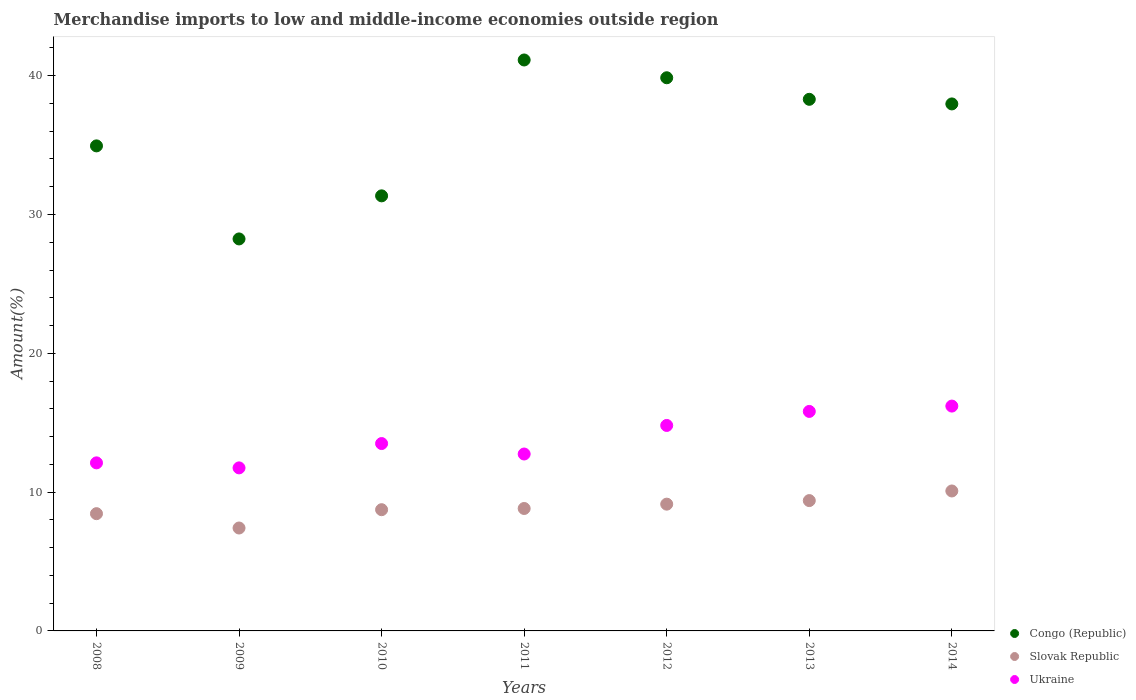How many different coloured dotlines are there?
Offer a terse response. 3. What is the percentage of amount earned from merchandise imports in Slovak Republic in 2012?
Give a very brief answer. 9.13. Across all years, what is the maximum percentage of amount earned from merchandise imports in Slovak Republic?
Make the answer very short. 10.08. Across all years, what is the minimum percentage of amount earned from merchandise imports in Slovak Republic?
Offer a terse response. 7.41. What is the total percentage of amount earned from merchandise imports in Slovak Republic in the graph?
Ensure brevity in your answer.  62.02. What is the difference between the percentage of amount earned from merchandise imports in Slovak Republic in 2010 and that in 2011?
Give a very brief answer. -0.09. What is the difference between the percentage of amount earned from merchandise imports in Ukraine in 2014 and the percentage of amount earned from merchandise imports in Congo (Republic) in 2010?
Keep it short and to the point. -15.15. What is the average percentage of amount earned from merchandise imports in Slovak Republic per year?
Your answer should be very brief. 8.86. In the year 2011, what is the difference between the percentage of amount earned from merchandise imports in Ukraine and percentage of amount earned from merchandise imports in Slovak Republic?
Your answer should be very brief. 3.92. What is the ratio of the percentage of amount earned from merchandise imports in Congo (Republic) in 2008 to that in 2009?
Provide a short and direct response. 1.24. Is the difference between the percentage of amount earned from merchandise imports in Ukraine in 2011 and 2013 greater than the difference between the percentage of amount earned from merchandise imports in Slovak Republic in 2011 and 2013?
Provide a succinct answer. No. What is the difference between the highest and the second highest percentage of amount earned from merchandise imports in Ukraine?
Offer a very short reply. 0.38. What is the difference between the highest and the lowest percentage of amount earned from merchandise imports in Congo (Republic)?
Make the answer very short. 12.89. In how many years, is the percentage of amount earned from merchandise imports in Congo (Republic) greater than the average percentage of amount earned from merchandise imports in Congo (Republic) taken over all years?
Your response must be concise. 4. Is the sum of the percentage of amount earned from merchandise imports in Ukraine in 2010 and 2011 greater than the maximum percentage of amount earned from merchandise imports in Congo (Republic) across all years?
Give a very brief answer. No. Is it the case that in every year, the sum of the percentage of amount earned from merchandise imports in Congo (Republic) and percentage of amount earned from merchandise imports in Ukraine  is greater than the percentage of amount earned from merchandise imports in Slovak Republic?
Provide a succinct answer. Yes. Is the percentage of amount earned from merchandise imports in Slovak Republic strictly less than the percentage of amount earned from merchandise imports in Ukraine over the years?
Your response must be concise. Yes. How many dotlines are there?
Your answer should be compact. 3. Does the graph contain any zero values?
Your response must be concise. No. Does the graph contain grids?
Provide a short and direct response. No. How many legend labels are there?
Ensure brevity in your answer.  3. How are the legend labels stacked?
Offer a terse response. Vertical. What is the title of the graph?
Offer a very short reply. Merchandise imports to low and middle-income economies outside region. Does "Kuwait" appear as one of the legend labels in the graph?
Your response must be concise. No. What is the label or title of the X-axis?
Your response must be concise. Years. What is the label or title of the Y-axis?
Provide a short and direct response. Amount(%). What is the Amount(%) in Congo (Republic) in 2008?
Offer a terse response. 34.94. What is the Amount(%) in Slovak Republic in 2008?
Provide a succinct answer. 8.45. What is the Amount(%) in Ukraine in 2008?
Provide a succinct answer. 12.11. What is the Amount(%) in Congo (Republic) in 2009?
Your answer should be compact. 28.24. What is the Amount(%) of Slovak Republic in 2009?
Offer a terse response. 7.41. What is the Amount(%) in Ukraine in 2009?
Offer a terse response. 11.75. What is the Amount(%) in Congo (Republic) in 2010?
Ensure brevity in your answer.  31.34. What is the Amount(%) in Slovak Republic in 2010?
Your answer should be very brief. 8.73. What is the Amount(%) of Ukraine in 2010?
Ensure brevity in your answer.  13.5. What is the Amount(%) of Congo (Republic) in 2011?
Keep it short and to the point. 41.13. What is the Amount(%) of Slovak Republic in 2011?
Ensure brevity in your answer.  8.82. What is the Amount(%) in Ukraine in 2011?
Your answer should be very brief. 12.74. What is the Amount(%) in Congo (Republic) in 2012?
Offer a very short reply. 39.85. What is the Amount(%) in Slovak Republic in 2012?
Provide a short and direct response. 9.13. What is the Amount(%) of Ukraine in 2012?
Offer a very short reply. 14.8. What is the Amount(%) of Congo (Republic) in 2013?
Ensure brevity in your answer.  38.3. What is the Amount(%) in Slovak Republic in 2013?
Make the answer very short. 9.39. What is the Amount(%) in Ukraine in 2013?
Offer a terse response. 15.81. What is the Amount(%) of Congo (Republic) in 2014?
Provide a short and direct response. 37.96. What is the Amount(%) of Slovak Republic in 2014?
Make the answer very short. 10.08. What is the Amount(%) of Ukraine in 2014?
Offer a terse response. 16.2. Across all years, what is the maximum Amount(%) in Congo (Republic)?
Your response must be concise. 41.13. Across all years, what is the maximum Amount(%) in Slovak Republic?
Your response must be concise. 10.08. Across all years, what is the maximum Amount(%) of Ukraine?
Keep it short and to the point. 16.2. Across all years, what is the minimum Amount(%) of Congo (Republic)?
Your response must be concise. 28.24. Across all years, what is the minimum Amount(%) in Slovak Republic?
Offer a terse response. 7.41. Across all years, what is the minimum Amount(%) of Ukraine?
Your answer should be compact. 11.75. What is the total Amount(%) in Congo (Republic) in the graph?
Offer a very short reply. 251.76. What is the total Amount(%) of Slovak Republic in the graph?
Your response must be concise. 62.02. What is the total Amount(%) of Ukraine in the graph?
Your response must be concise. 96.91. What is the difference between the Amount(%) of Congo (Republic) in 2008 and that in 2009?
Give a very brief answer. 6.7. What is the difference between the Amount(%) of Slovak Republic in 2008 and that in 2009?
Your answer should be very brief. 1.03. What is the difference between the Amount(%) of Ukraine in 2008 and that in 2009?
Your answer should be compact. 0.36. What is the difference between the Amount(%) in Congo (Republic) in 2008 and that in 2010?
Your answer should be very brief. 3.6. What is the difference between the Amount(%) of Slovak Republic in 2008 and that in 2010?
Make the answer very short. -0.29. What is the difference between the Amount(%) in Ukraine in 2008 and that in 2010?
Keep it short and to the point. -1.39. What is the difference between the Amount(%) of Congo (Republic) in 2008 and that in 2011?
Your response must be concise. -6.19. What is the difference between the Amount(%) of Slovak Republic in 2008 and that in 2011?
Your response must be concise. -0.37. What is the difference between the Amount(%) in Ukraine in 2008 and that in 2011?
Your answer should be very brief. -0.64. What is the difference between the Amount(%) of Congo (Republic) in 2008 and that in 2012?
Keep it short and to the point. -4.91. What is the difference between the Amount(%) in Slovak Republic in 2008 and that in 2012?
Keep it short and to the point. -0.69. What is the difference between the Amount(%) in Ukraine in 2008 and that in 2012?
Provide a short and direct response. -2.69. What is the difference between the Amount(%) in Congo (Republic) in 2008 and that in 2013?
Make the answer very short. -3.35. What is the difference between the Amount(%) in Slovak Republic in 2008 and that in 2013?
Provide a succinct answer. -0.94. What is the difference between the Amount(%) of Ukraine in 2008 and that in 2013?
Give a very brief answer. -3.71. What is the difference between the Amount(%) in Congo (Republic) in 2008 and that in 2014?
Offer a very short reply. -3.02. What is the difference between the Amount(%) in Slovak Republic in 2008 and that in 2014?
Your response must be concise. -1.64. What is the difference between the Amount(%) in Ukraine in 2008 and that in 2014?
Give a very brief answer. -4.09. What is the difference between the Amount(%) in Congo (Republic) in 2009 and that in 2010?
Give a very brief answer. -3.1. What is the difference between the Amount(%) in Slovak Republic in 2009 and that in 2010?
Provide a succinct answer. -1.32. What is the difference between the Amount(%) of Ukraine in 2009 and that in 2010?
Give a very brief answer. -1.75. What is the difference between the Amount(%) in Congo (Republic) in 2009 and that in 2011?
Make the answer very short. -12.89. What is the difference between the Amount(%) of Slovak Republic in 2009 and that in 2011?
Offer a terse response. -1.41. What is the difference between the Amount(%) of Ukraine in 2009 and that in 2011?
Provide a succinct answer. -1. What is the difference between the Amount(%) of Congo (Republic) in 2009 and that in 2012?
Offer a very short reply. -11.61. What is the difference between the Amount(%) in Slovak Republic in 2009 and that in 2012?
Your response must be concise. -1.72. What is the difference between the Amount(%) of Ukraine in 2009 and that in 2012?
Provide a short and direct response. -3.06. What is the difference between the Amount(%) in Congo (Republic) in 2009 and that in 2013?
Offer a terse response. -10.06. What is the difference between the Amount(%) in Slovak Republic in 2009 and that in 2013?
Your response must be concise. -1.97. What is the difference between the Amount(%) of Ukraine in 2009 and that in 2013?
Keep it short and to the point. -4.07. What is the difference between the Amount(%) of Congo (Republic) in 2009 and that in 2014?
Your response must be concise. -9.73. What is the difference between the Amount(%) of Slovak Republic in 2009 and that in 2014?
Your answer should be compact. -2.67. What is the difference between the Amount(%) of Ukraine in 2009 and that in 2014?
Make the answer very short. -4.45. What is the difference between the Amount(%) in Congo (Republic) in 2010 and that in 2011?
Keep it short and to the point. -9.79. What is the difference between the Amount(%) of Slovak Republic in 2010 and that in 2011?
Offer a very short reply. -0.09. What is the difference between the Amount(%) of Ukraine in 2010 and that in 2011?
Provide a succinct answer. 0.75. What is the difference between the Amount(%) in Congo (Republic) in 2010 and that in 2012?
Your response must be concise. -8.51. What is the difference between the Amount(%) of Slovak Republic in 2010 and that in 2012?
Make the answer very short. -0.4. What is the difference between the Amount(%) of Ukraine in 2010 and that in 2012?
Provide a short and direct response. -1.3. What is the difference between the Amount(%) in Congo (Republic) in 2010 and that in 2013?
Your response must be concise. -6.95. What is the difference between the Amount(%) in Slovak Republic in 2010 and that in 2013?
Provide a short and direct response. -0.66. What is the difference between the Amount(%) in Ukraine in 2010 and that in 2013?
Your answer should be very brief. -2.31. What is the difference between the Amount(%) in Congo (Republic) in 2010 and that in 2014?
Keep it short and to the point. -6.62. What is the difference between the Amount(%) of Slovak Republic in 2010 and that in 2014?
Give a very brief answer. -1.35. What is the difference between the Amount(%) of Ukraine in 2010 and that in 2014?
Offer a terse response. -2.7. What is the difference between the Amount(%) in Congo (Republic) in 2011 and that in 2012?
Ensure brevity in your answer.  1.28. What is the difference between the Amount(%) in Slovak Republic in 2011 and that in 2012?
Your answer should be compact. -0.31. What is the difference between the Amount(%) in Ukraine in 2011 and that in 2012?
Your answer should be compact. -2.06. What is the difference between the Amount(%) of Congo (Republic) in 2011 and that in 2013?
Keep it short and to the point. 2.83. What is the difference between the Amount(%) in Slovak Republic in 2011 and that in 2013?
Your answer should be very brief. -0.57. What is the difference between the Amount(%) in Ukraine in 2011 and that in 2013?
Ensure brevity in your answer.  -3.07. What is the difference between the Amount(%) of Congo (Republic) in 2011 and that in 2014?
Offer a terse response. 3.17. What is the difference between the Amount(%) of Slovak Republic in 2011 and that in 2014?
Provide a succinct answer. -1.26. What is the difference between the Amount(%) of Ukraine in 2011 and that in 2014?
Ensure brevity in your answer.  -3.45. What is the difference between the Amount(%) in Congo (Republic) in 2012 and that in 2013?
Ensure brevity in your answer.  1.55. What is the difference between the Amount(%) in Slovak Republic in 2012 and that in 2013?
Offer a terse response. -0.26. What is the difference between the Amount(%) of Ukraine in 2012 and that in 2013?
Provide a succinct answer. -1.01. What is the difference between the Amount(%) of Congo (Republic) in 2012 and that in 2014?
Your answer should be compact. 1.88. What is the difference between the Amount(%) of Slovak Republic in 2012 and that in 2014?
Keep it short and to the point. -0.95. What is the difference between the Amount(%) of Ukraine in 2012 and that in 2014?
Provide a succinct answer. -1.4. What is the difference between the Amount(%) in Congo (Republic) in 2013 and that in 2014?
Offer a very short reply. 0.33. What is the difference between the Amount(%) in Slovak Republic in 2013 and that in 2014?
Your answer should be compact. -0.69. What is the difference between the Amount(%) in Ukraine in 2013 and that in 2014?
Provide a short and direct response. -0.38. What is the difference between the Amount(%) of Congo (Republic) in 2008 and the Amount(%) of Slovak Republic in 2009?
Provide a short and direct response. 27.53. What is the difference between the Amount(%) of Congo (Republic) in 2008 and the Amount(%) of Ukraine in 2009?
Your answer should be compact. 23.2. What is the difference between the Amount(%) in Slovak Republic in 2008 and the Amount(%) in Ukraine in 2009?
Your response must be concise. -3.3. What is the difference between the Amount(%) in Congo (Republic) in 2008 and the Amount(%) in Slovak Republic in 2010?
Offer a terse response. 26.21. What is the difference between the Amount(%) in Congo (Republic) in 2008 and the Amount(%) in Ukraine in 2010?
Make the answer very short. 21.44. What is the difference between the Amount(%) of Slovak Republic in 2008 and the Amount(%) of Ukraine in 2010?
Provide a succinct answer. -5.05. What is the difference between the Amount(%) of Congo (Republic) in 2008 and the Amount(%) of Slovak Republic in 2011?
Offer a very short reply. 26.12. What is the difference between the Amount(%) of Congo (Republic) in 2008 and the Amount(%) of Ukraine in 2011?
Keep it short and to the point. 22.2. What is the difference between the Amount(%) in Slovak Republic in 2008 and the Amount(%) in Ukraine in 2011?
Your answer should be very brief. -4.3. What is the difference between the Amount(%) in Congo (Republic) in 2008 and the Amount(%) in Slovak Republic in 2012?
Ensure brevity in your answer.  25.81. What is the difference between the Amount(%) in Congo (Republic) in 2008 and the Amount(%) in Ukraine in 2012?
Give a very brief answer. 20.14. What is the difference between the Amount(%) of Slovak Republic in 2008 and the Amount(%) of Ukraine in 2012?
Make the answer very short. -6.36. What is the difference between the Amount(%) of Congo (Republic) in 2008 and the Amount(%) of Slovak Republic in 2013?
Make the answer very short. 25.55. What is the difference between the Amount(%) in Congo (Republic) in 2008 and the Amount(%) in Ukraine in 2013?
Provide a short and direct response. 19.13. What is the difference between the Amount(%) of Slovak Republic in 2008 and the Amount(%) of Ukraine in 2013?
Your response must be concise. -7.37. What is the difference between the Amount(%) in Congo (Republic) in 2008 and the Amount(%) in Slovak Republic in 2014?
Offer a terse response. 24.86. What is the difference between the Amount(%) of Congo (Republic) in 2008 and the Amount(%) of Ukraine in 2014?
Keep it short and to the point. 18.74. What is the difference between the Amount(%) of Slovak Republic in 2008 and the Amount(%) of Ukraine in 2014?
Keep it short and to the point. -7.75. What is the difference between the Amount(%) of Congo (Republic) in 2009 and the Amount(%) of Slovak Republic in 2010?
Offer a terse response. 19.51. What is the difference between the Amount(%) in Congo (Republic) in 2009 and the Amount(%) in Ukraine in 2010?
Your answer should be very brief. 14.74. What is the difference between the Amount(%) of Slovak Republic in 2009 and the Amount(%) of Ukraine in 2010?
Keep it short and to the point. -6.08. What is the difference between the Amount(%) of Congo (Republic) in 2009 and the Amount(%) of Slovak Republic in 2011?
Provide a succinct answer. 19.42. What is the difference between the Amount(%) of Congo (Republic) in 2009 and the Amount(%) of Ukraine in 2011?
Keep it short and to the point. 15.49. What is the difference between the Amount(%) in Slovak Republic in 2009 and the Amount(%) in Ukraine in 2011?
Provide a succinct answer. -5.33. What is the difference between the Amount(%) of Congo (Republic) in 2009 and the Amount(%) of Slovak Republic in 2012?
Keep it short and to the point. 19.11. What is the difference between the Amount(%) in Congo (Republic) in 2009 and the Amount(%) in Ukraine in 2012?
Keep it short and to the point. 13.44. What is the difference between the Amount(%) in Slovak Republic in 2009 and the Amount(%) in Ukraine in 2012?
Keep it short and to the point. -7.39. What is the difference between the Amount(%) of Congo (Republic) in 2009 and the Amount(%) of Slovak Republic in 2013?
Your answer should be compact. 18.85. What is the difference between the Amount(%) of Congo (Republic) in 2009 and the Amount(%) of Ukraine in 2013?
Provide a succinct answer. 12.43. What is the difference between the Amount(%) of Slovak Republic in 2009 and the Amount(%) of Ukraine in 2013?
Offer a terse response. -8.4. What is the difference between the Amount(%) of Congo (Republic) in 2009 and the Amount(%) of Slovak Republic in 2014?
Your response must be concise. 18.16. What is the difference between the Amount(%) of Congo (Republic) in 2009 and the Amount(%) of Ukraine in 2014?
Make the answer very short. 12.04. What is the difference between the Amount(%) of Slovak Republic in 2009 and the Amount(%) of Ukraine in 2014?
Your answer should be compact. -8.78. What is the difference between the Amount(%) in Congo (Republic) in 2010 and the Amount(%) in Slovak Republic in 2011?
Offer a terse response. 22.52. What is the difference between the Amount(%) in Congo (Republic) in 2010 and the Amount(%) in Ukraine in 2011?
Your answer should be compact. 18.6. What is the difference between the Amount(%) in Slovak Republic in 2010 and the Amount(%) in Ukraine in 2011?
Your answer should be very brief. -4.01. What is the difference between the Amount(%) in Congo (Republic) in 2010 and the Amount(%) in Slovak Republic in 2012?
Give a very brief answer. 22.21. What is the difference between the Amount(%) of Congo (Republic) in 2010 and the Amount(%) of Ukraine in 2012?
Your answer should be very brief. 16.54. What is the difference between the Amount(%) of Slovak Republic in 2010 and the Amount(%) of Ukraine in 2012?
Keep it short and to the point. -6.07. What is the difference between the Amount(%) of Congo (Republic) in 2010 and the Amount(%) of Slovak Republic in 2013?
Your answer should be very brief. 21.95. What is the difference between the Amount(%) in Congo (Republic) in 2010 and the Amount(%) in Ukraine in 2013?
Give a very brief answer. 15.53. What is the difference between the Amount(%) of Slovak Republic in 2010 and the Amount(%) of Ukraine in 2013?
Your response must be concise. -7.08. What is the difference between the Amount(%) in Congo (Republic) in 2010 and the Amount(%) in Slovak Republic in 2014?
Your answer should be very brief. 21.26. What is the difference between the Amount(%) in Congo (Republic) in 2010 and the Amount(%) in Ukraine in 2014?
Make the answer very short. 15.15. What is the difference between the Amount(%) in Slovak Republic in 2010 and the Amount(%) in Ukraine in 2014?
Your answer should be very brief. -7.46. What is the difference between the Amount(%) in Congo (Republic) in 2011 and the Amount(%) in Slovak Republic in 2012?
Offer a terse response. 32. What is the difference between the Amount(%) of Congo (Republic) in 2011 and the Amount(%) of Ukraine in 2012?
Ensure brevity in your answer.  26.33. What is the difference between the Amount(%) of Slovak Republic in 2011 and the Amount(%) of Ukraine in 2012?
Your response must be concise. -5.98. What is the difference between the Amount(%) in Congo (Republic) in 2011 and the Amount(%) in Slovak Republic in 2013?
Make the answer very short. 31.74. What is the difference between the Amount(%) of Congo (Republic) in 2011 and the Amount(%) of Ukraine in 2013?
Keep it short and to the point. 25.32. What is the difference between the Amount(%) in Slovak Republic in 2011 and the Amount(%) in Ukraine in 2013?
Your answer should be very brief. -6.99. What is the difference between the Amount(%) in Congo (Republic) in 2011 and the Amount(%) in Slovak Republic in 2014?
Make the answer very short. 31.05. What is the difference between the Amount(%) of Congo (Republic) in 2011 and the Amount(%) of Ukraine in 2014?
Make the answer very short. 24.93. What is the difference between the Amount(%) of Slovak Republic in 2011 and the Amount(%) of Ukraine in 2014?
Your answer should be compact. -7.38. What is the difference between the Amount(%) in Congo (Republic) in 2012 and the Amount(%) in Slovak Republic in 2013?
Offer a terse response. 30.46. What is the difference between the Amount(%) in Congo (Republic) in 2012 and the Amount(%) in Ukraine in 2013?
Give a very brief answer. 24.04. What is the difference between the Amount(%) in Slovak Republic in 2012 and the Amount(%) in Ukraine in 2013?
Your answer should be compact. -6.68. What is the difference between the Amount(%) in Congo (Republic) in 2012 and the Amount(%) in Slovak Republic in 2014?
Make the answer very short. 29.77. What is the difference between the Amount(%) in Congo (Republic) in 2012 and the Amount(%) in Ukraine in 2014?
Make the answer very short. 23.65. What is the difference between the Amount(%) of Slovak Republic in 2012 and the Amount(%) of Ukraine in 2014?
Provide a short and direct response. -7.06. What is the difference between the Amount(%) in Congo (Republic) in 2013 and the Amount(%) in Slovak Republic in 2014?
Your response must be concise. 28.21. What is the difference between the Amount(%) in Congo (Republic) in 2013 and the Amount(%) in Ukraine in 2014?
Give a very brief answer. 22.1. What is the difference between the Amount(%) of Slovak Republic in 2013 and the Amount(%) of Ukraine in 2014?
Give a very brief answer. -6.81. What is the average Amount(%) of Congo (Republic) per year?
Offer a very short reply. 35.97. What is the average Amount(%) of Slovak Republic per year?
Offer a terse response. 8.86. What is the average Amount(%) of Ukraine per year?
Offer a terse response. 13.84. In the year 2008, what is the difference between the Amount(%) in Congo (Republic) and Amount(%) in Slovak Republic?
Provide a succinct answer. 26.5. In the year 2008, what is the difference between the Amount(%) of Congo (Republic) and Amount(%) of Ukraine?
Make the answer very short. 22.83. In the year 2008, what is the difference between the Amount(%) in Slovak Republic and Amount(%) in Ukraine?
Offer a very short reply. -3.66. In the year 2009, what is the difference between the Amount(%) of Congo (Republic) and Amount(%) of Slovak Republic?
Offer a terse response. 20.83. In the year 2009, what is the difference between the Amount(%) of Congo (Republic) and Amount(%) of Ukraine?
Your answer should be compact. 16.49. In the year 2009, what is the difference between the Amount(%) in Slovak Republic and Amount(%) in Ukraine?
Provide a short and direct response. -4.33. In the year 2010, what is the difference between the Amount(%) of Congo (Republic) and Amount(%) of Slovak Republic?
Ensure brevity in your answer.  22.61. In the year 2010, what is the difference between the Amount(%) in Congo (Republic) and Amount(%) in Ukraine?
Provide a succinct answer. 17.84. In the year 2010, what is the difference between the Amount(%) of Slovak Republic and Amount(%) of Ukraine?
Your response must be concise. -4.76. In the year 2011, what is the difference between the Amount(%) of Congo (Republic) and Amount(%) of Slovak Republic?
Offer a terse response. 32.31. In the year 2011, what is the difference between the Amount(%) of Congo (Republic) and Amount(%) of Ukraine?
Offer a very short reply. 28.39. In the year 2011, what is the difference between the Amount(%) in Slovak Republic and Amount(%) in Ukraine?
Make the answer very short. -3.92. In the year 2012, what is the difference between the Amount(%) in Congo (Republic) and Amount(%) in Slovak Republic?
Your response must be concise. 30.72. In the year 2012, what is the difference between the Amount(%) of Congo (Republic) and Amount(%) of Ukraine?
Give a very brief answer. 25.05. In the year 2012, what is the difference between the Amount(%) of Slovak Republic and Amount(%) of Ukraine?
Offer a very short reply. -5.67. In the year 2013, what is the difference between the Amount(%) of Congo (Republic) and Amount(%) of Slovak Republic?
Provide a short and direct response. 28.91. In the year 2013, what is the difference between the Amount(%) of Congo (Republic) and Amount(%) of Ukraine?
Offer a very short reply. 22.48. In the year 2013, what is the difference between the Amount(%) in Slovak Republic and Amount(%) in Ukraine?
Your answer should be compact. -6.42. In the year 2014, what is the difference between the Amount(%) in Congo (Republic) and Amount(%) in Slovak Republic?
Provide a short and direct response. 27.88. In the year 2014, what is the difference between the Amount(%) of Congo (Republic) and Amount(%) of Ukraine?
Make the answer very short. 21.77. In the year 2014, what is the difference between the Amount(%) in Slovak Republic and Amount(%) in Ukraine?
Ensure brevity in your answer.  -6.12. What is the ratio of the Amount(%) of Congo (Republic) in 2008 to that in 2009?
Offer a very short reply. 1.24. What is the ratio of the Amount(%) in Slovak Republic in 2008 to that in 2009?
Your response must be concise. 1.14. What is the ratio of the Amount(%) of Ukraine in 2008 to that in 2009?
Your response must be concise. 1.03. What is the ratio of the Amount(%) of Congo (Republic) in 2008 to that in 2010?
Your response must be concise. 1.11. What is the ratio of the Amount(%) of Slovak Republic in 2008 to that in 2010?
Ensure brevity in your answer.  0.97. What is the ratio of the Amount(%) of Ukraine in 2008 to that in 2010?
Your response must be concise. 0.9. What is the ratio of the Amount(%) of Congo (Republic) in 2008 to that in 2011?
Provide a short and direct response. 0.85. What is the ratio of the Amount(%) in Slovak Republic in 2008 to that in 2011?
Provide a short and direct response. 0.96. What is the ratio of the Amount(%) of Congo (Republic) in 2008 to that in 2012?
Give a very brief answer. 0.88. What is the ratio of the Amount(%) of Slovak Republic in 2008 to that in 2012?
Offer a very short reply. 0.92. What is the ratio of the Amount(%) in Ukraine in 2008 to that in 2012?
Provide a succinct answer. 0.82. What is the ratio of the Amount(%) in Congo (Republic) in 2008 to that in 2013?
Your answer should be compact. 0.91. What is the ratio of the Amount(%) in Slovak Republic in 2008 to that in 2013?
Offer a terse response. 0.9. What is the ratio of the Amount(%) in Ukraine in 2008 to that in 2013?
Give a very brief answer. 0.77. What is the ratio of the Amount(%) of Congo (Republic) in 2008 to that in 2014?
Provide a succinct answer. 0.92. What is the ratio of the Amount(%) of Slovak Republic in 2008 to that in 2014?
Keep it short and to the point. 0.84. What is the ratio of the Amount(%) in Ukraine in 2008 to that in 2014?
Keep it short and to the point. 0.75. What is the ratio of the Amount(%) in Congo (Republic) in 2009 to that in 2010?
Provide a succinct answer. 0.9. What is the ratio of the Amount(%) in Slovak Republic in 2009 to that in 2010?
Offer a very short reply. 0.85. What is the ratio of the Amount(%) in Ukraine in 2009 to that in 2010?
Give a very brief answer. 0.87. What is the ratio of the Amount(%) in Congo (Republic) in 2009 to that in 2011?
Give a very brief answer. 0.69. What is the ratio of the Amount(%) of Slovak Republic in 2009 to that in 2011?
Your response must be concise. 0.84. What is the ratio of the Amount(%) of Ukraine in 2009 to that in 2011?
Offer a very short reply. 0.92. What is the ratio of the Amount(%) in Congo (Republic) in 2009 to that in 2012?
Offer a terse response. 0.71. What is the ratio of the Amount(%) of Slovak Republic in 2009 to that in 2012?
Your answer should be very brief. 0.81. What is the ratio of the Amount(%) in Ukraine in 2009 to that in 2012?
Provide a succinct answer. 0.79. What is the ratio of the Amount(%) in Congo (Republic) in 2009 to that in 2013?
Provide a short and direct response. 0.74. What is the ratio of the Amount(%) in Slovak Republic in 2009 to that in 2013?
Offer a terse response. 0.79. What is the ratio of the Amount(%) of Ukraine in 2009 to that in 2013?
Offer a terse response. 0.74. What is the ratio of the Amount(%) of Congo (Republic) in 2009 to that in 2014?
Keep it short and to the point. 0.74. What is the ratio of the Amount(%) in Slovak Republic in 2009 to that in 2014?
Provide a short and direct response. 0.74. What is the ratio of the Amount(%) in Ukraine in 2009 to that in 2014?
Keep it short and to the point. 0.73. What is the ratio of the Amount(%) of Congo (Republic) in 2010 to that in 2011?
Your answer should be very brief. 0.76. What is the ratio of the Amount(%) in Ukraine in 2010 to that in 2011?
Ensure brevity in your answer.  1.06. What is the ratio of the Amount(%) in Congo (Republic) in 2010 to that in 2012?
Provide a short and direct response. 0.79. What is the ratio of the Amount(%) of Slovak Republic in 2010 to that in 2012?
Keep it short and to the point. 0.96. What is the ratio of the Amount(%) in Ukraine in 2010 to that in 2012?
Ensure brevity in your answer.  0.91. What is the ratio of the Amount(%) of Congo (Republic) in 2010 to that in 2013?
Your answer should be compact. 0.82. What is the ratio of the Amount(%) in Slovak Republic in 2010 to that in 2013?
Provide a short and direct response. 0.93. What is the ratio of the Amount(%) in Ukraine in 2010 to that in 2013?
Your answer should be very brief. 0.85. What is the ratio of the Amount(%) in Congo (Republic) in 2010 to that in 2014?
Your answer should be compact. 0.83. What is the ratio of the Amount(%) of Slovak Republic in 2010 to that in 2014?
Give a very brief answer. 0.87. What is the ratio of the Amount(%) in Ukraine in 2010 to that in 2014?
Your answer should be compact. 0.83. What is the ratio of the Amount(%) in Congo (Republic) in 2011 to that in 2012?
Offer a terse response. 1.03. What is the ratio of the Amount(%) in Slovak Republic in 2011 to that in 2012?
Provide a short and direct response. 0.97. What is the ratio of the Amount(%) of Ukraine in 2011 to that in 2012?
Offer a very short reply. 0.86. What is the ratio of the Amount(%) of Congo (Republic) in 2011 to that in 2013?
Make the answer very short. 1.07. What is the ratio of the Amount(%) of Slovak Republic in 2011 to that in 2013?
Provide a short and direct response. 0.94. What is the ratio of the Amount(%) in Ukraine in 2011 to that in 2013?
Offer a very short reply. 0.81. What is the ratio of the Amount(%) of Congo (Republic) in 2011 to that in 2014?
Provide a short and direct response. 1.08. What is the ratio of the Amount(%) of Slovak Republic in 2011 to that in 2014?
Offer a terse response. 0.87. What is the ratio of the Amount(%) of Ukraine in 2011 to that in 2014?
Your answer should be very brief. 0.79. What is the ratio of the Amount(%) in Congo (Republic) in 2012 to that in 2013?
Give a very brief answer. 1.04. What is the ratio of the Amount(%) of Slovak Republic in 2012 to that in 2013?
Give a very brief answer. 0.97. What is the ratio of the Amount(%) in Ukraine in 2012 to that in 2013?
Make the answer very short. 0.94. What is the ratio of the Amount(%) in Congo (Republic) in 2012 to that in 2014?
Give a very brief answer. 1.05. What is the ratio of the Amount(%) of Slovak Republic in 2012 to that in 2014?
Provide a short and direct response. 0.91. What is the ratio of the Amount(%) in Ukraine in 2012 to that in 2014?
Make the answer very short. 0.91. What is the ratio of the Amount(%) of Congo (Republic) in 2013 to that in 2014?
Keep it short and to the point. 1.01. What is the ratio of the Amount(%) in Slovak Republic in 2013 to that in 2014?
Your answer should be very brief. 0.93. What is the ratio of the Amount(%) in Ukraine in 2013 to that in 2014?
Offer a very short reply. 0.98. What is the difference between the highest and the second highest Amount(%) in Congo (Republic)?
Ensure brevity in your answer.  1.28. What is the difference between the highest and the second highest Amount(%) of Slovak Republic?
Give a very brief answer. 0.69. What is the difference between the highest and the second highest Amount(%) in Ukraine?
Provide a succinct answer. 0.38. What is the difference between the highest and the lowest Amount(%) of Congo (Republic)?
Keep it short and to the point. 12.89. What is the difference between the highest and the lowest Amount(%) in Slovak Republic?
Give a very brief answer. 2.67. What is the difference between the highest and the lowest Amount(%) in Ukraine?
Make the answer very short. 4.45. 